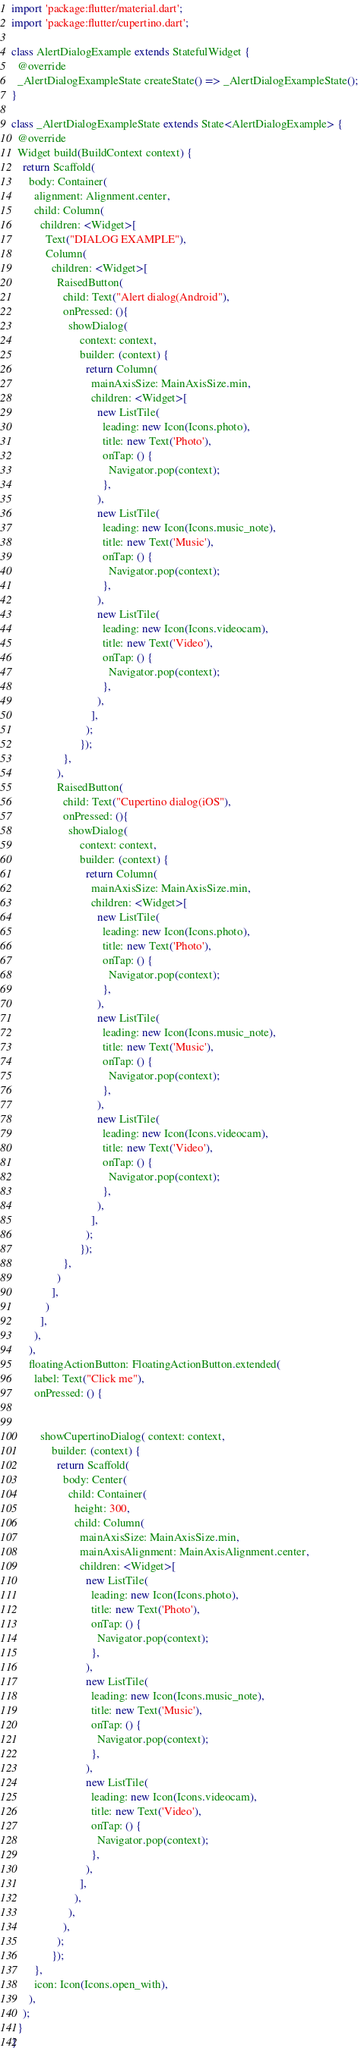<code> <loc_0><loc_0><loc_500><loc_500><_Dart_>import 'package:flutter/material.dart';
import 'package:flutter/cupertino.dart';

class AlertDialogExample extends StatefulWidget {
  @override
  _AlertDialogExampleState createState() => _AlertDialogExampleState();
}

class _AlertDialogExampleState extends State<AlertDialogExample> {
  @override
  Widget build(BuildContext context) {
    return Scaffold(
      body: Container(
        alignment: Alignment.center,
        child: Column(
          children: <Widget>[
            Text("DIALOG EXAMPLE"),
            Column(
              children: <Widget>[
                RaisedButton(
                  child: Text("Alert dialog(Android"),
                  onPressed: (){
                    showDialog(
                        context: context,
                        builder: (context) {
                          return Column(
                            mainAxisSize: MainAxisSize.min,
                            children: <Widget>[
                              new ListTile(
                                leading: new Icon(Icons.photo),
                                title: new Text('Photo'),
                                onTap: () {
                                  Navigator.pop(context);
                                },
                              ),
                              new ListTile(
                                leading: new Icon(Icons.music_note),
                                title: new Text('Music'),
                                onTap: () {
                                  Navigator.pop(context);
                                },
                              ),
                              new ListTile(
                                leading: new Icon(Icons.videocam),
                                title: new Text('Video'),
                                onTap: () {
                                  Navigator.pop(context);
                                },
                              ),
                            ],
                          );
                        });
                  },
                ),
                RaisedButton(
                  child: Text("Cupertino dialog(iOS"),
                  onPressed: (){
                    showDialog(
                        context: context,
                        builder: (context) {
                          return Column(
                            mainAxisSize: MainAxisSize.min,
                            children: <Widget>[
                              new ListTile(
                                leading: new Icon(Icons.photo),
                                title: new Text('Photo'),
                                onTap: () {
                                  Navigator.pop(context);
                                },
                              ),
                              new ListTile(
                                leading: new Icon(Icons.music_note),
                                title: new Text('Music'),
                                onTap: () {
                                  Navigator.pop(context);
                                },
                              ),
                              new ListTile(
                                leading: new Icon(Icons.videocam),
                                title: new Text('Video'),
                                onTap: () {
                                  Navigator.pop(context);
                                },
                              ),
                            ],
                          );
                        });
                  },
                )
              ],
            )
          ],
        ),
      ),
      floatingActionButton: FloatingActionButton.extended(
        label: Text("Click me"),
        onPressed: () {


          showCupertinoDialog( context: context,
              builder: (context) {
                return Scaffold(
                  body: Center(
                    child: Container(
                      height: 300,
                      child: Column(
                        mainAxisSize: MainAxisSize.min,
                        mainAxisAlignment: MainAxisAlignment.center,
                        children: <Widget>[
                          new ListTile(
                            leading: new Icon(Icons.photo),
                            title: new Text('Photo'),
                            onTap: () {
                              Navigator.pop(context);
                            },
                          ),
                          new ListTile(
                            leading: new Icon(Icons.music_note),
                            title: new Text('Music'),
                            onTap: () {
                              Navigator.pop(context);
                            },
                          ),
                          new ListTile(
                            leading: new Icon(Icons.videocam),
                            title: new Text('Video'),
                            onTap: () {
                              Navigator.pop(context);
                            },
                          ),
                        ],
                      ),
                    ),
                  ),
                );
              });
        },
        icon: Icon(Icons.open_with),
      ),
    );
  }
}
</code> 